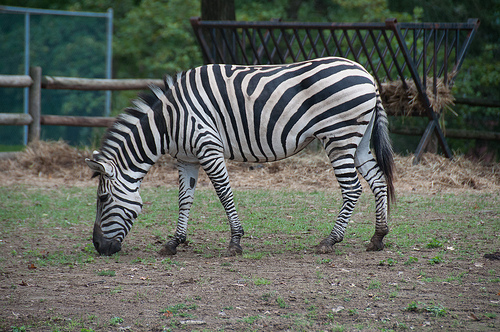Please describe the landscape surrounding the zebra. The zebra is in a grassy field, possibly within a large enclosure or zoo, with minimal vegetation other than a few bushes and sparse grass. There's also a visible wooden fence in the background, likely indicating a managed habitat. 